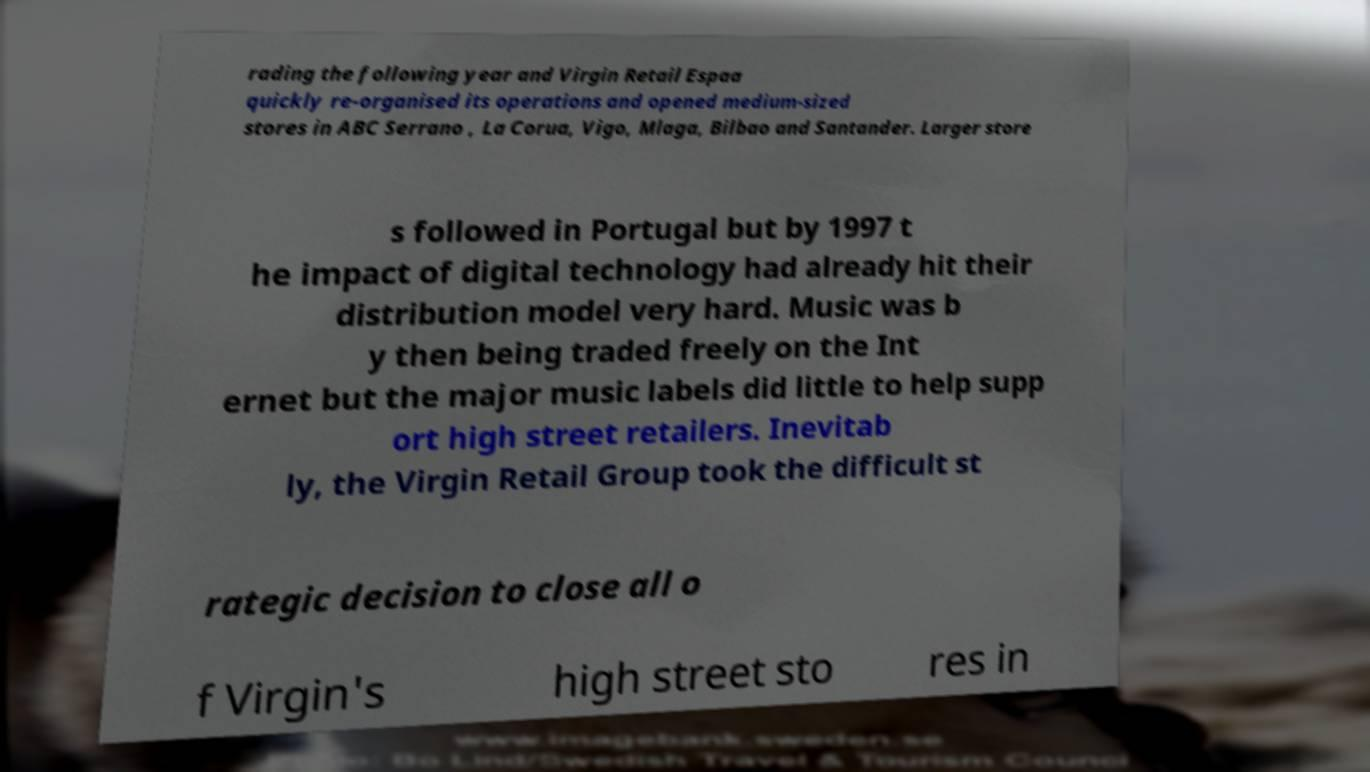There's text embedded in this image that I need extracted. Can you transcribe it verbatim? rading the following year and Virgin Retail Espaa quickly re-organised its operations and opened medium-sized stores in ABC Serrano , La Corua, Vigo, Mlaga, Bilbao and Santander. Larger store s followed in Portugal but by 1997 t he impact of digital technology had already hit their distribution model very hard. Music was b y then being traded freely on the Int ernet but the major music labels did little to help supp ort high street retailers. Inevitab ly, the Virgin Retail Group took the difficult st rategic decision to close all o f Virgin's high street sto res in 